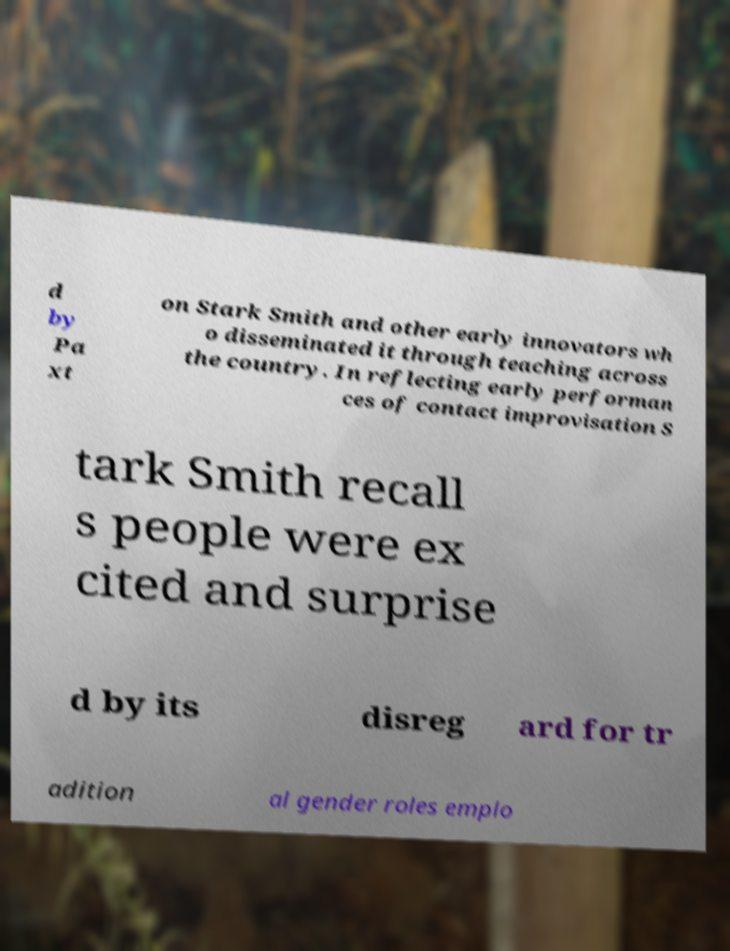Can you read and provide the text displayed in the image?This photo seems to have some interesting text. Can you extract and type it out for me? d by Pa xt on Stark Smith and other early innovators wh o disseminated it through teaching across the country. In reflecting early performan ces of contact improvisation S tark Smith recall s people were ex cited and surprise d by its disreg ard for tr adition al gender roles emplo 